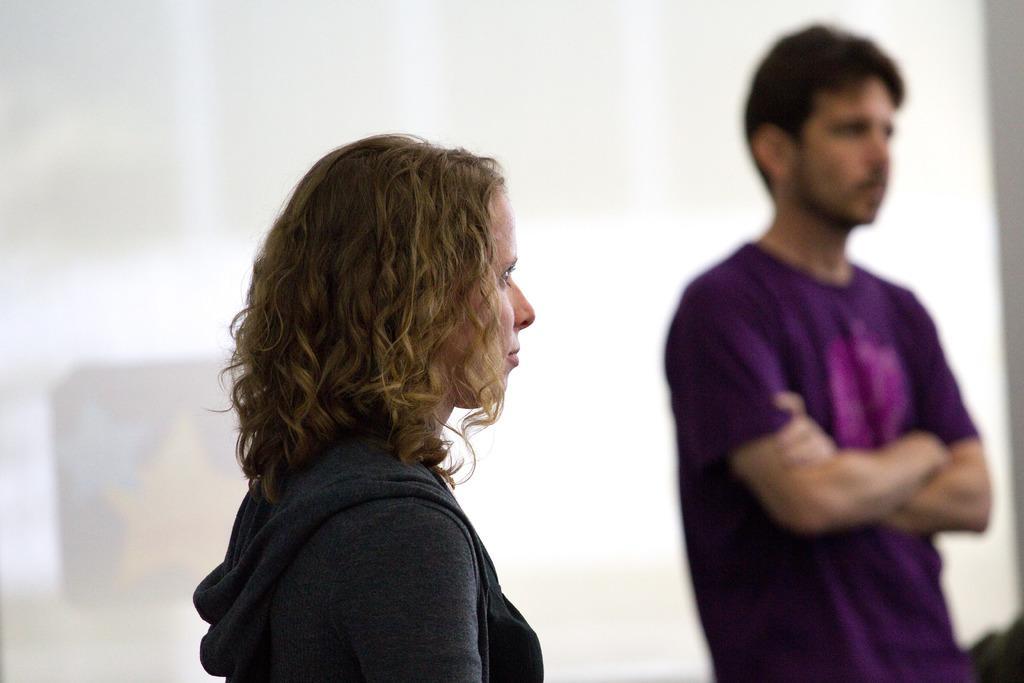In one or two sentences, can you explain what this image depicts? In this picture we can observe two members. One of them is a woman wearing black color hoodie and the other is a man wearing violet color T shirt. Both of them were standing. The background is in white color. 